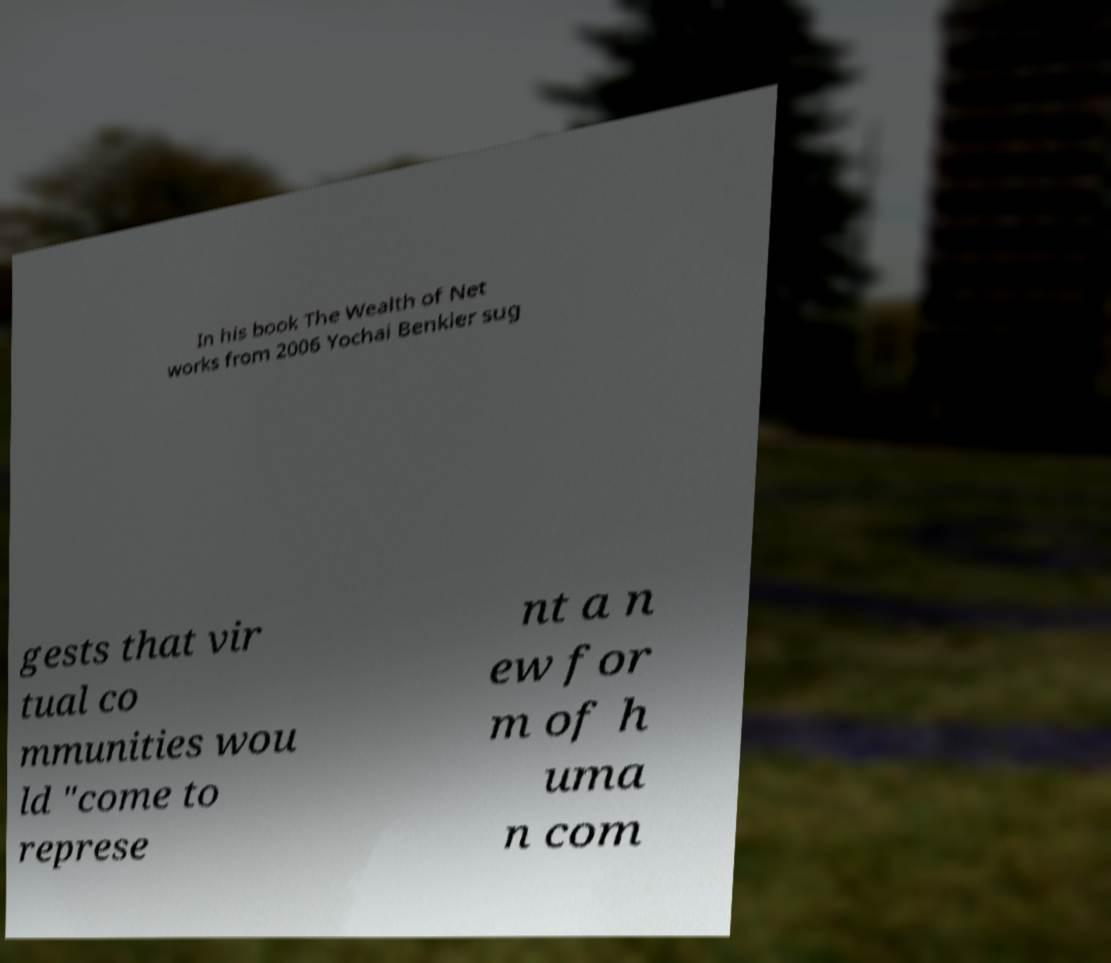I need the written content from this picture converted into text. Can you do that? In his book The Wealth of Net works from 2006 Yochai Benkler sug gests that vir tual co mmunities wou ld "come to represe nt a n ew for m of h uma n com 